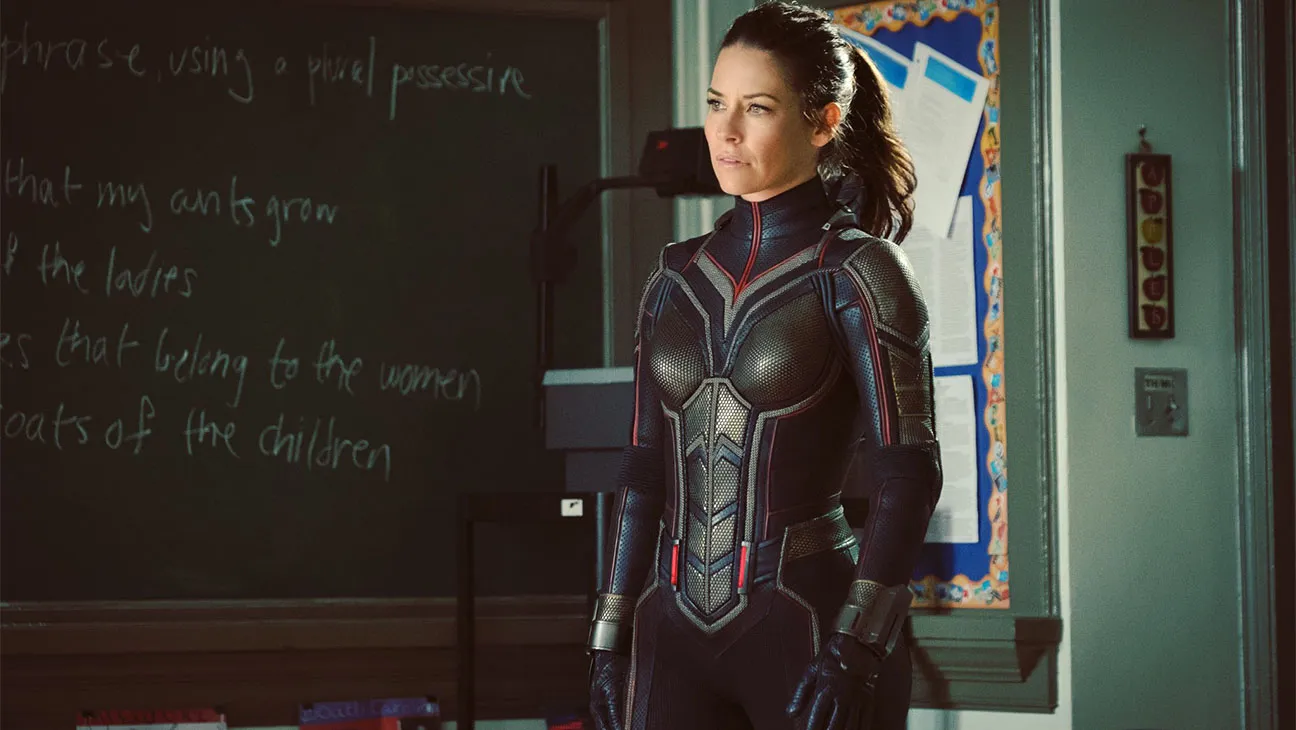Can you describe the main features of this image for me? The image showcases a woman in a highly detailed superhero suit. She stands in a classroom, indicated by the chalkboard and the bulletin board full of papers and drawings in the background. The suit is primarily black with silver accents and features intricate design elements. She also wears a matching helmet, which is tucked under her arm. Her expression is focused and serious, directed towards something off-frame, suggesting she is deep in thought or responding to an intense situation. 